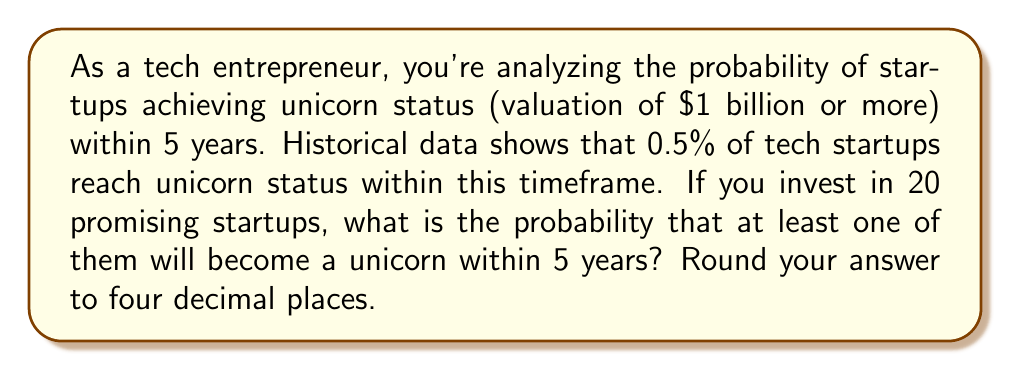Can you answer this question? Let's approach this step-by-step:

1) First, let's define our probability:
   $p$ = probability of a startup becoming a unicorn within 5 years = 0.005 (0.5%)

2) The probability of a startup not becoming a unicorn is:
   $1 - p = 1 - 0.005 = 0.995$

3) We want the probability of at least one startup out of 20 becoming a unicorn. It's easier to calculate the probability of no startups becoming unicorns and then subtract this from 1.

4) The probability of no startups out of 20 becoming unicorns is:
   $(0.995)^{20}$

5) Therefore, the probability of at least one startup becoming a unicorn is:
   $1 - (0.995)^{20}$

6) Let's calculate:
   $1 - (0.995)^{20} = 1 - 0.9048 = 0.0952$

7) Rounding to four decimal places:
   $0.0952 \approx 0.0952$

Thus, the probability is approximately 0.0952 or 9.52%.
Answer: 0.0952 